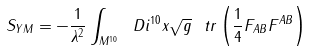<formula> <loc_0><loc_0><loc_500><loc_500>S _ { Y M } = - \frac { 1 } { \lambda ^ { 2 } } \int _ { M ^ { 1 0 } } \ D i ^ { 1 0 } x \sqrt { g } \ t r \left ( \frac { 1 } { 4 } F _ { A B } F ^ { A B } \right )</formula> 